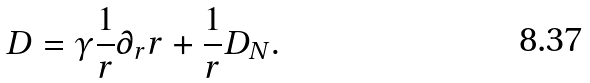<formula> <loc_0><loc_0><loc_500><loc_500>D = \gamma \frac { 1 } { r } \partial _ { r } r + \frac { 1 } { r } D _ { N } .</formula> 